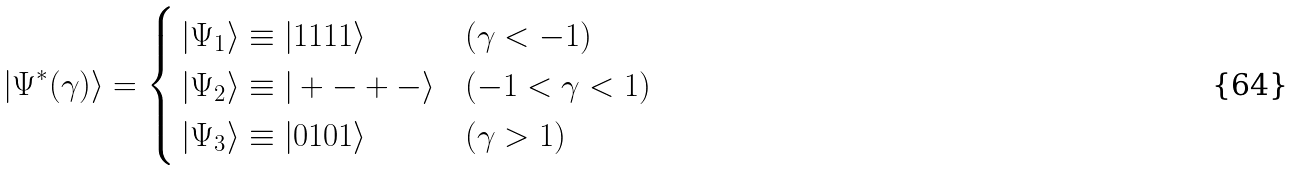Convert formula to latex. <formula><loc_0><loc_0><loc_500><loc_500>| \Psi ^ { * } ( \gamma ) \rangle = \begin{cases} \, | \Psi _ { 1 } \rangle \equiv | 1 1 1 1 \rangle & ( \gamma < - 1 ) \\ \, | \Psi _ { 2 } \rangle \equiv | + - + - \rangle & ( - 1 < \gamma < 1 ) \\ \, | \Psi _ { 3 } \rangle \equiv | 0 1 0 1 \rangle & ( \gamma > 1 ) \end{cases}</formula> 